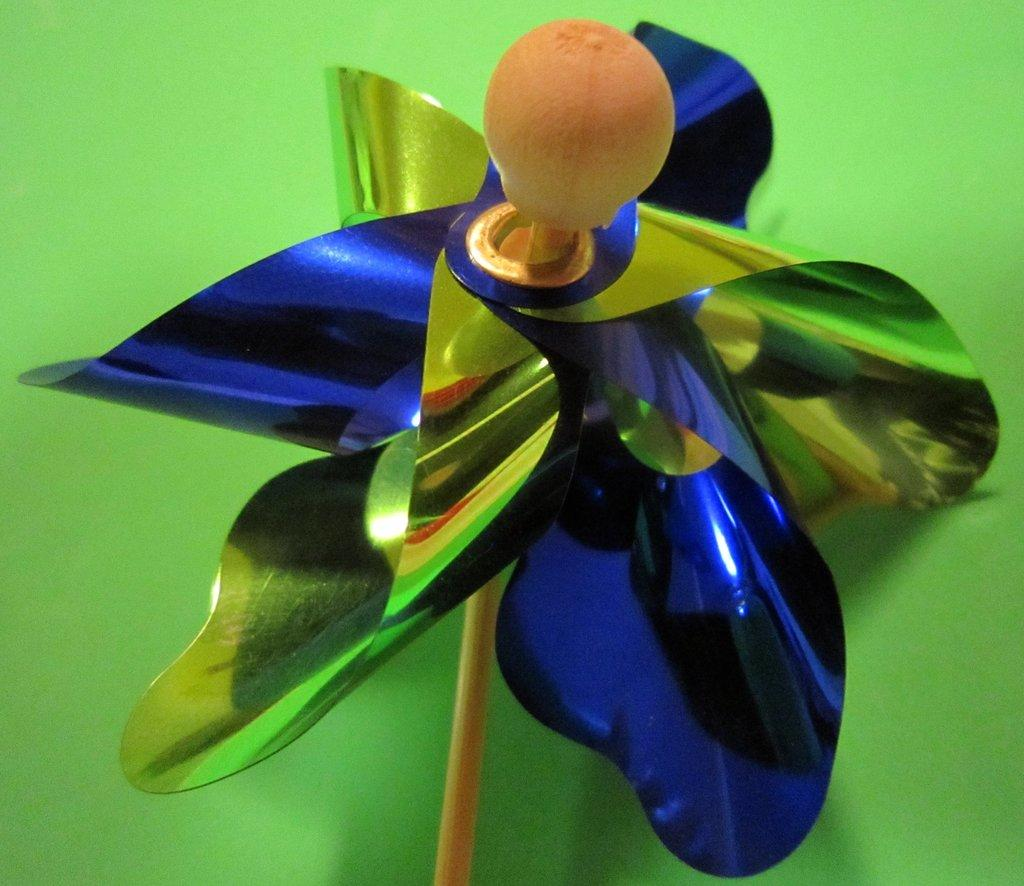What is the main subject of the image? There is an object in the center of the image. What color is the background of the image? The background of the image is green. Is the object in the image providing shade for its partner? There is no indication of a partner or shade in the image, as it only features an object in the center and a green background. 